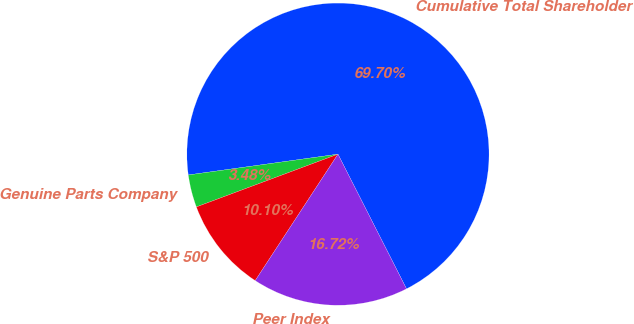Convert chart to OTSL. <chart><loc_0><loc_0><loc_500><loc_500><pie_chart><fcel>Cumulative Total Shareholder<fcel>Genuine Parts Company<fcel>S&P 500<fcel>Peer Index<nl><fcel>69.7%<fcel>3.48%<fcel>10.1%<fcel>16.72%<nl></chart> 